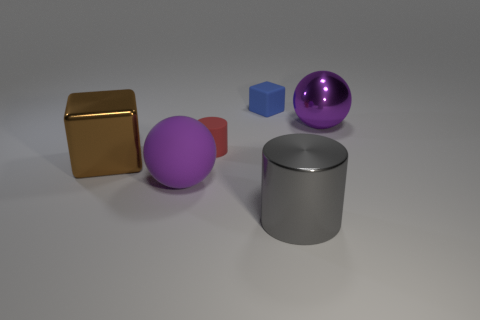Do the sphere to the left of the metal cylinder and the large metallic ball have the same color?
Your answer should be compact. Yes. What material is the other big ball that is the same color as the large matte sphere?
Give a very brief answer. Metal. Are there any metallic balls that have the same color as the big matte thing?
Keep it short and to the point. Yes. Is there a tiny red cylinder made of the same material as the small blue block?
Provide a succinct answer. Yes. What material is the big purple object behind the large purple object to the left of the purple metallic ball?
Ensure brevity in your answer.  Metal. There is a object that is left of the purple shiny object and behind the matte cylinder; what material is it?
Provide a succinct answer. Rubber. Is the number of large purple matte objects that are in front of the large matte thing the same as the number of cyan shiny cylinders?
Your response must be concise. Yes. What number of other big purple metallic things have the same shape as the large purple shiny object?
Keep it short and to the point. 0. There is a block in front of the purple object that is behind the big metallic object to the left of the large gray cylinder; what is its size?
Make the answer very short. Large. Is the material of the large purple object that is behind the small cylinder the same as the gray object?
Ensure brevity in your answer.  Yes. 